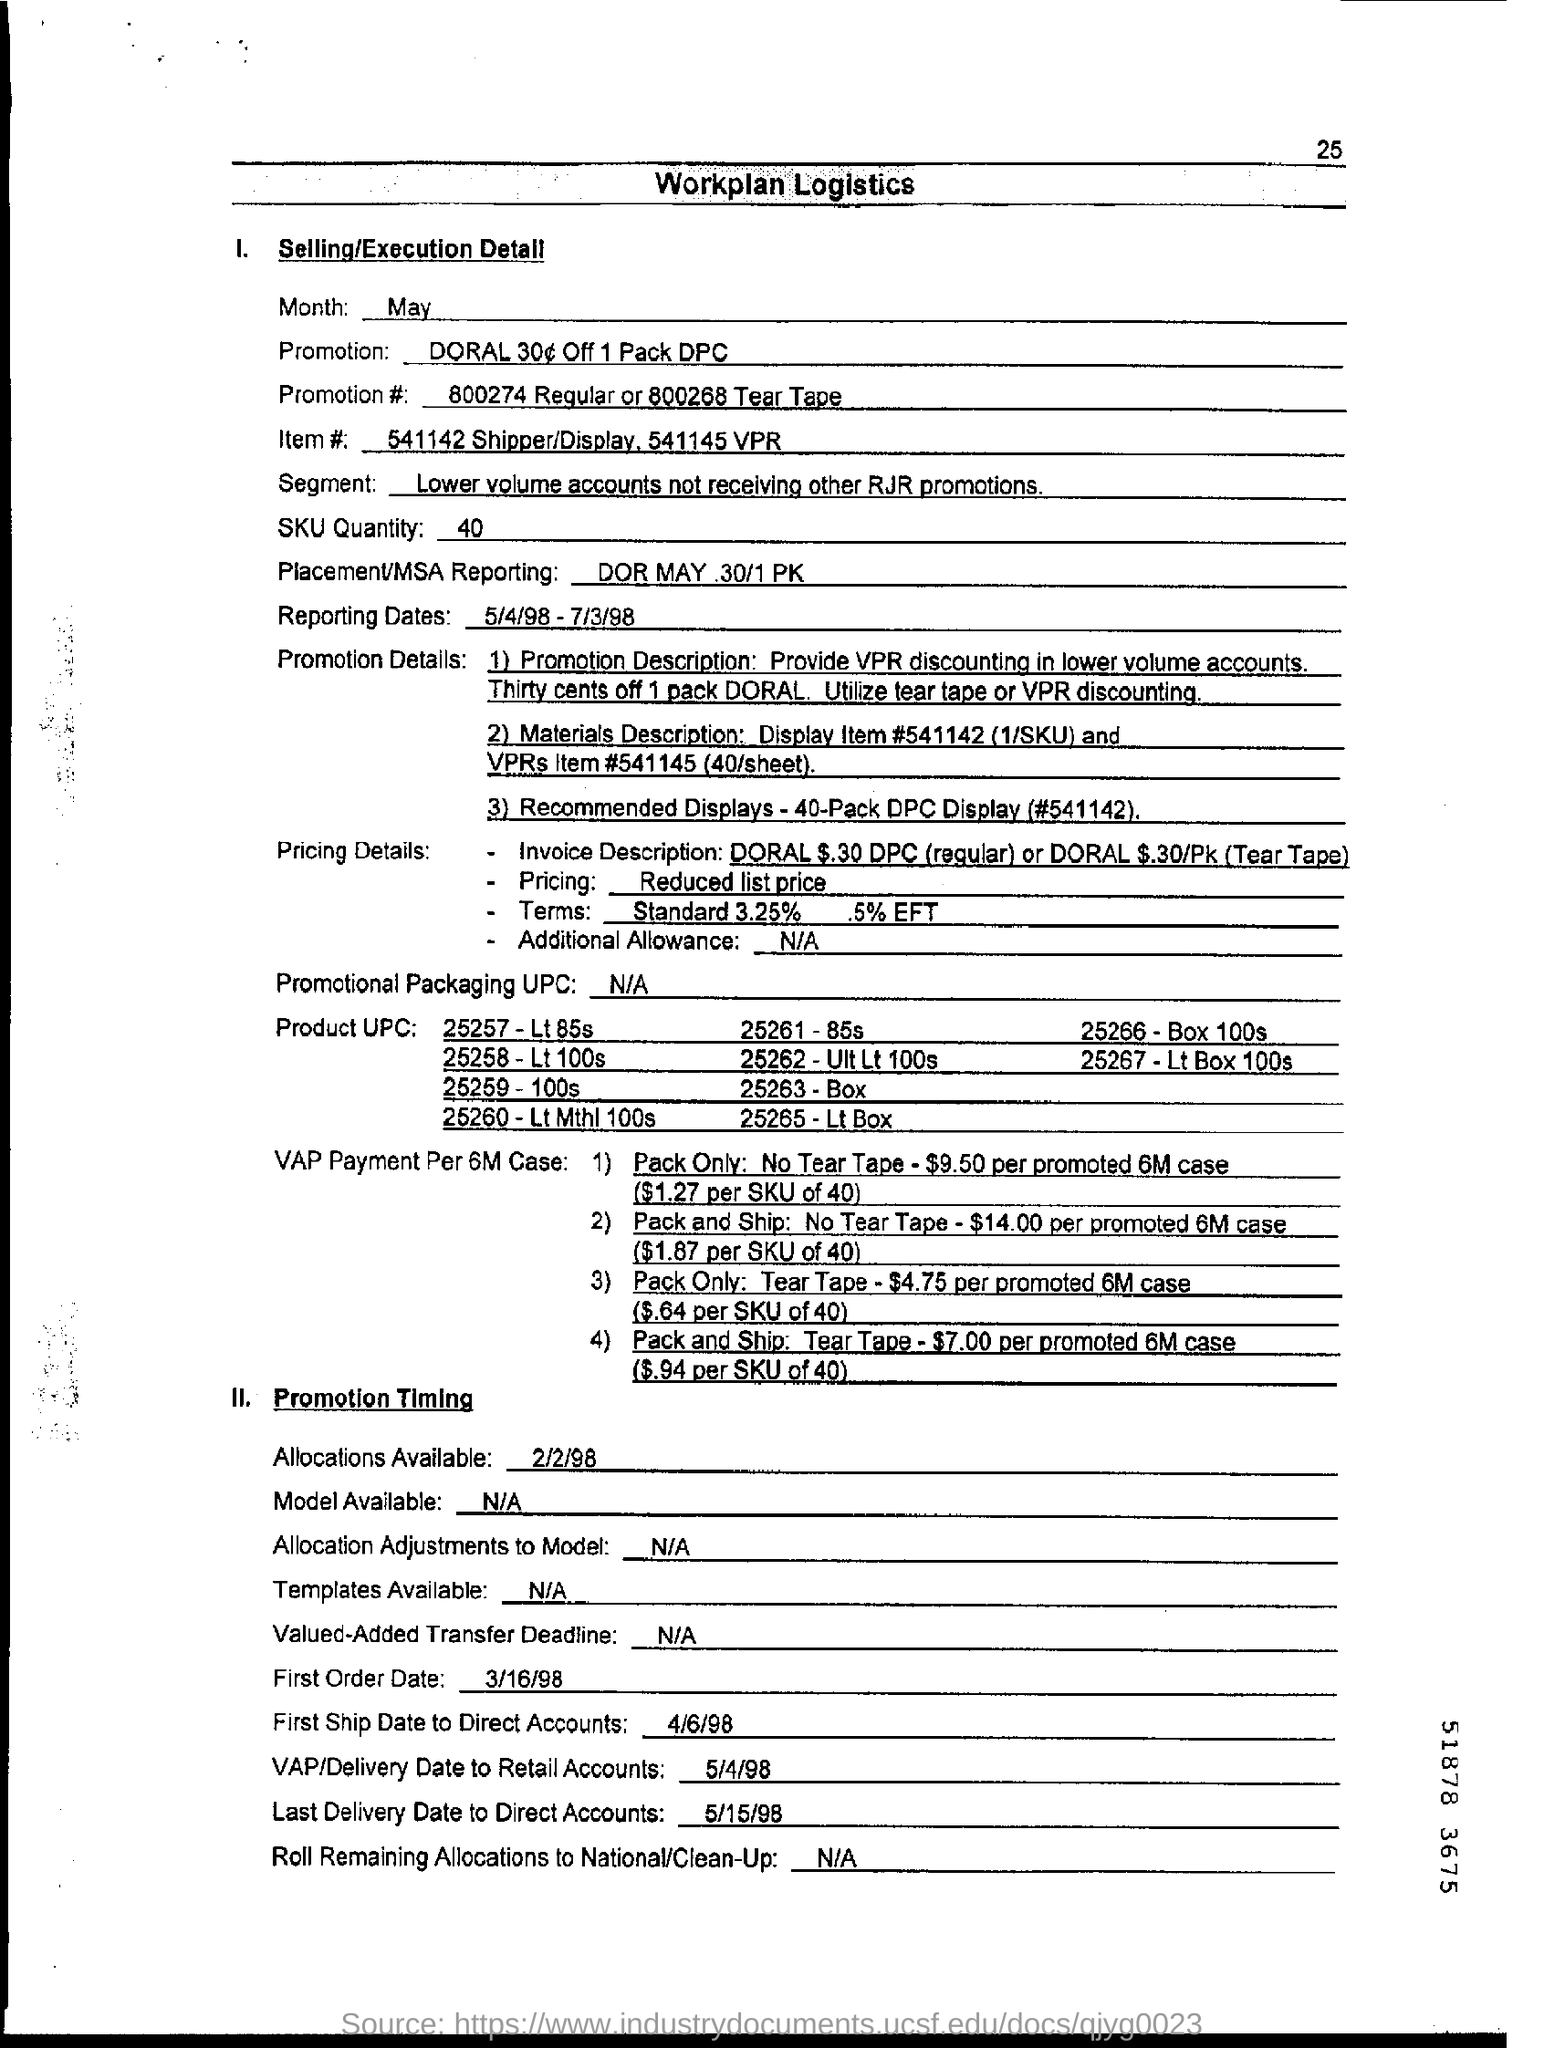What is the eft percentage
Provide a short and direct response. .5%. What is the last delivery date to direct accounts
Provide a short and direct response. 5/15/98. 